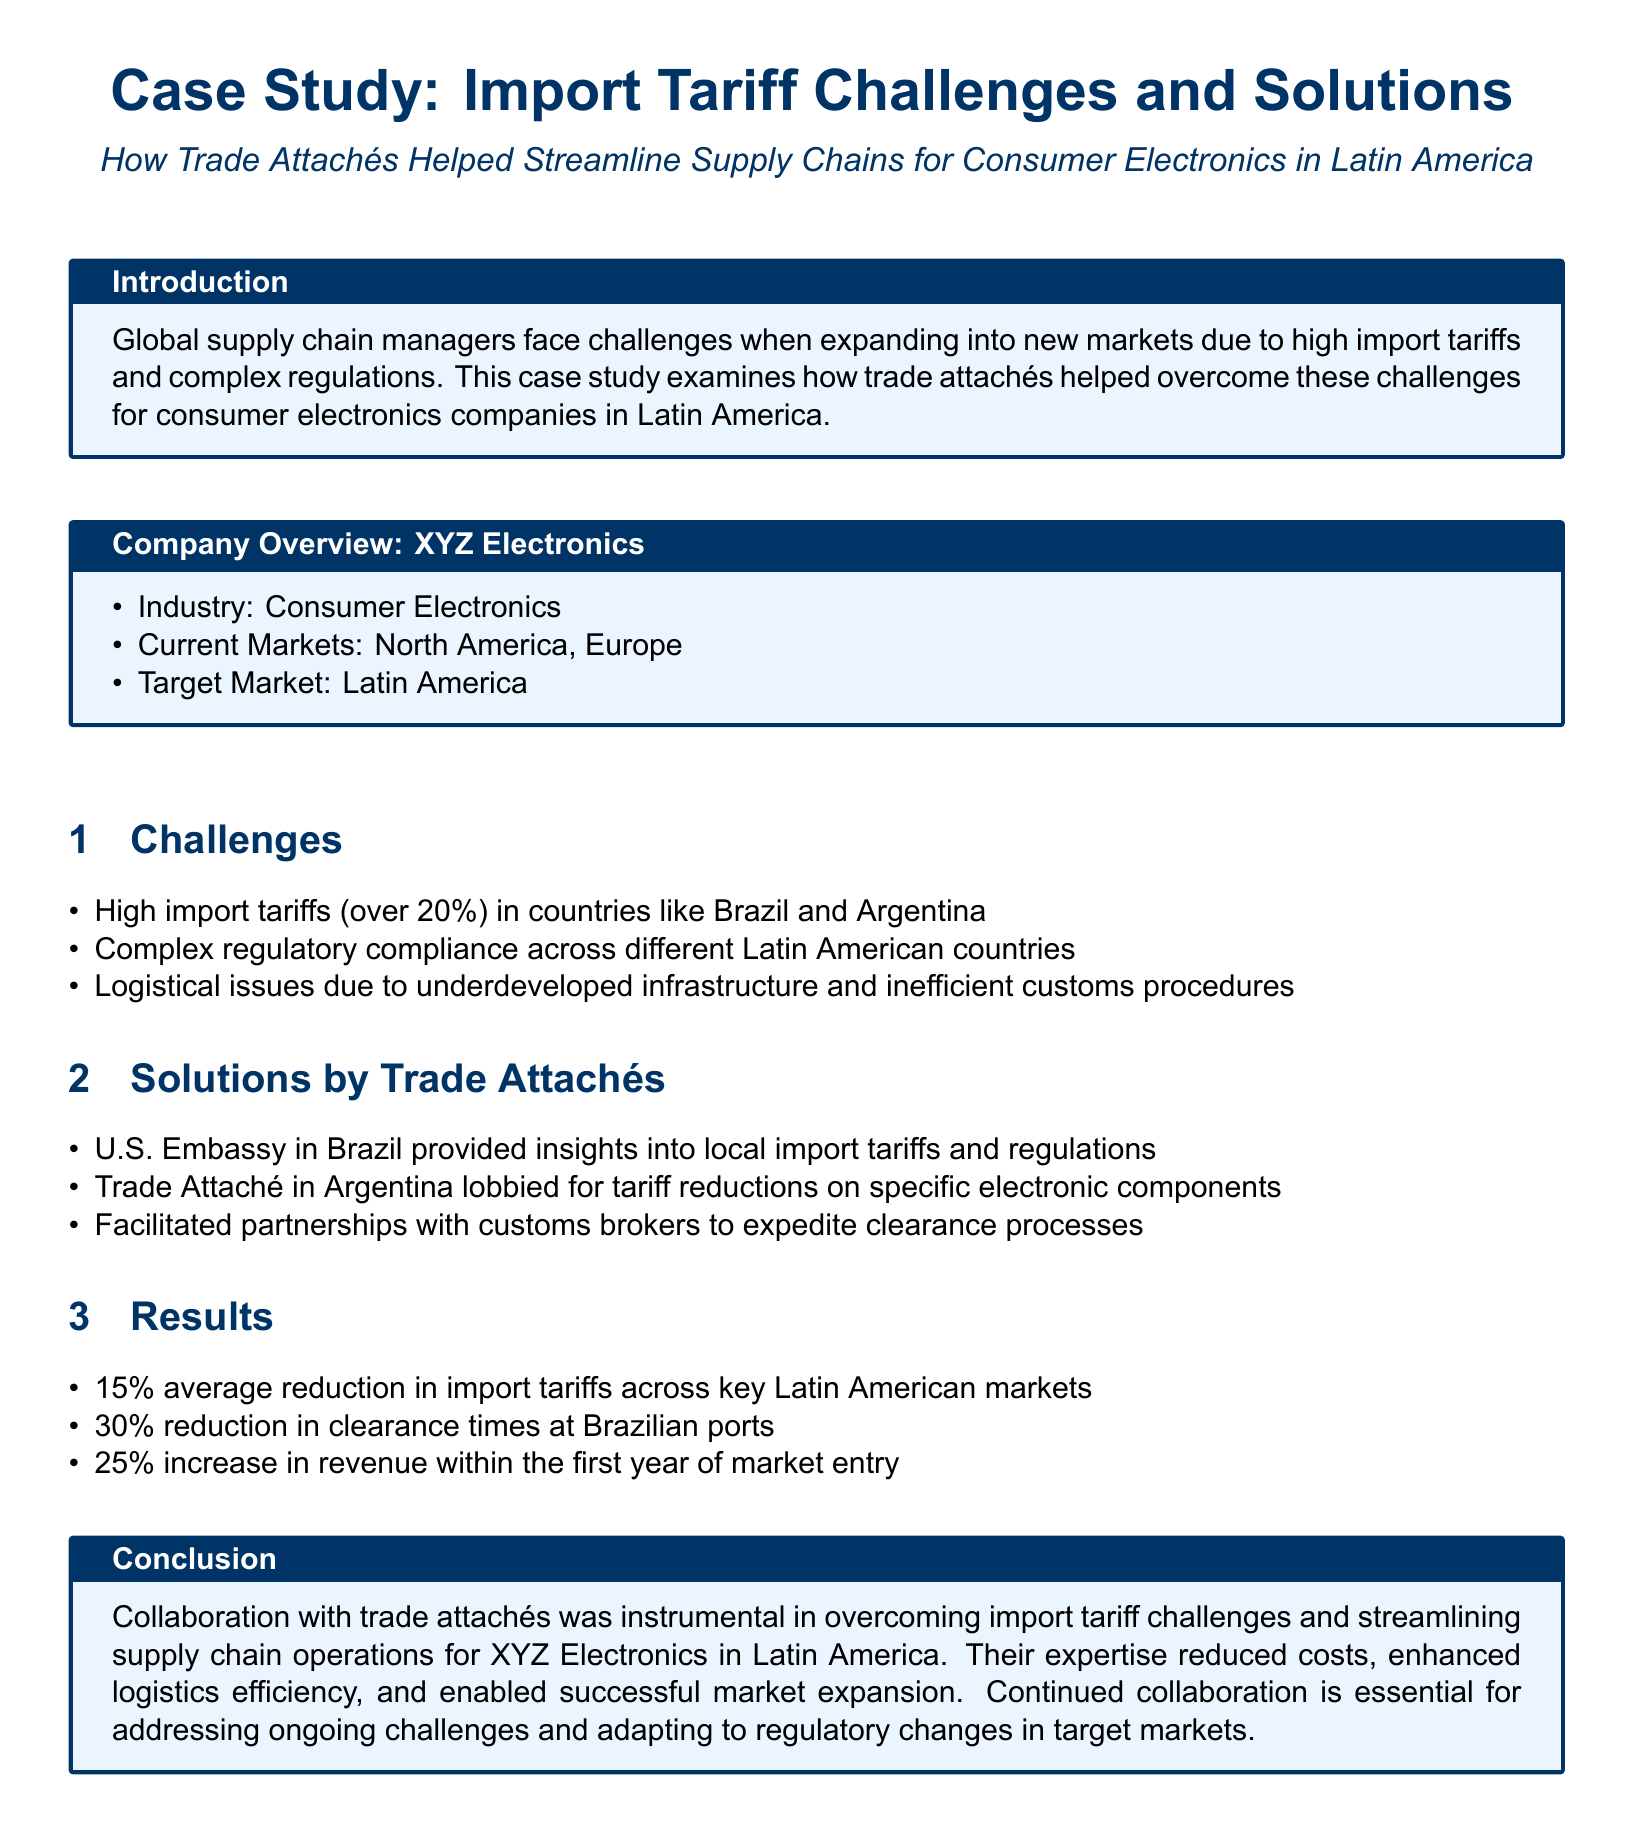what was the average reduction in import tariffs? The document states there was a 15% average reduction in import tariffs across key Latin American markets.
Answer: 15% which country had over 20% import tariffs? Brazil and Argentina are mentioned as having high import tariffs over 20%.
Answer: Brazil and Argentina what was the increase in revenue within the first year? The document mentions a 25% increase in revenue within the first year of market entry.
Answer: 25% what logistical issue was highlighted? The document states that there are logistical issues due to underdeveloped infrastructure and inefficient customs procedures.
Answer: Underdeveloped infrastructure who lobbied for tariff reductions in Argentina? The Trade Attaché in Argentina is mentioned as the one who lobbied for tariff reductions on specific electronic components.
Answer: Trade Attaché what was the reduction in clearance times at Brazilian ports? The document claims there was a 30% reduction in clearance times at Brazilian ports.
Answer: 30% what is the primary focus of the case study? The case study focuses on how trade attachés helped streamline supply chains for consumer electronics in Latin America.
Answer: Streamline supply chains for consumer electronics which department provided insights into local import tariffs in Brazil? The U.S. Embassy in Brazil is noted for providing insights into local import tariffs and regulations.
Answer: U.S. Embassy in Brazil what is the target market for XYZ Electronics? The document specifies that the target market for XYZ Electronics is Latin America.
Answer: Latin America what was one of the challenges faced by global supply chain managers? The case study identifies high import tariffs as one of the challenges faced when expanding into new markets.
Answer: High import tariffs 